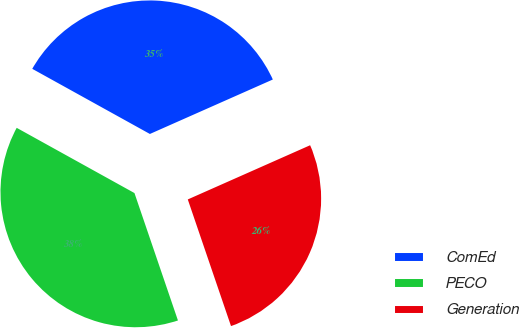Convert chart. <chart><loc_0><loc_0><loc_500><loc_500><pie_chart><fcel>ComEd<fcel>PECO<fcel>Generation<nl><fcel>35.31%<fcel>38.28%<fcel>26.4%<nl></chart> 